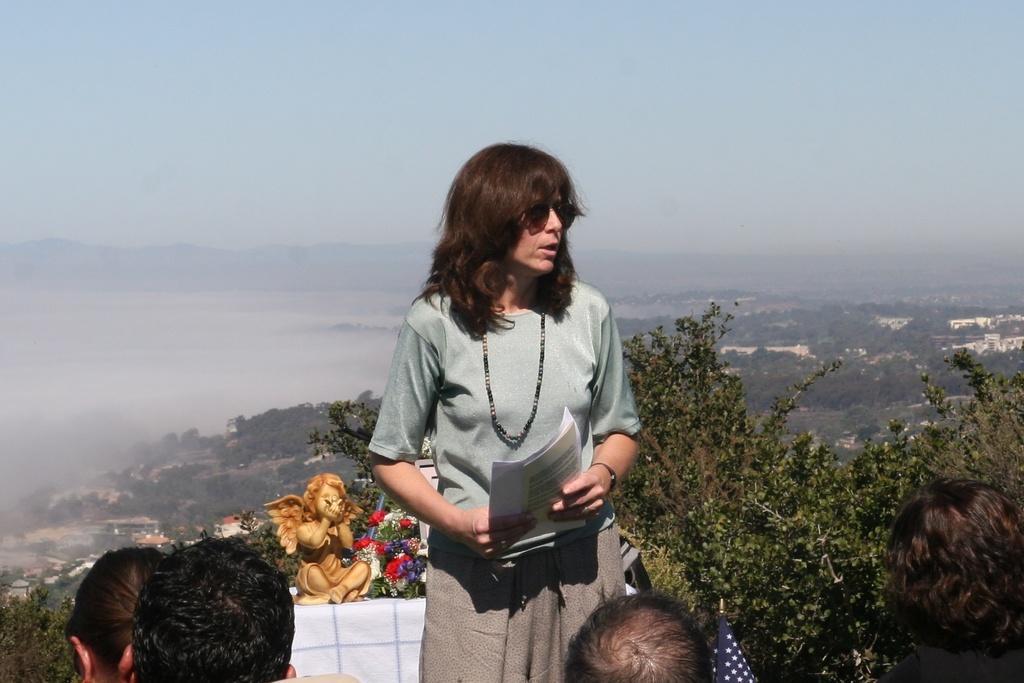Describe this image in one or two sentences. In this image I can see a woman is standing in the centre and I can see she is holding few papers. In the front of her I can see few people and a flag. In the background I can see few trees, few flowers and a mini sculpture. I can also see number of trees, number of buildings and the sky in the background. 